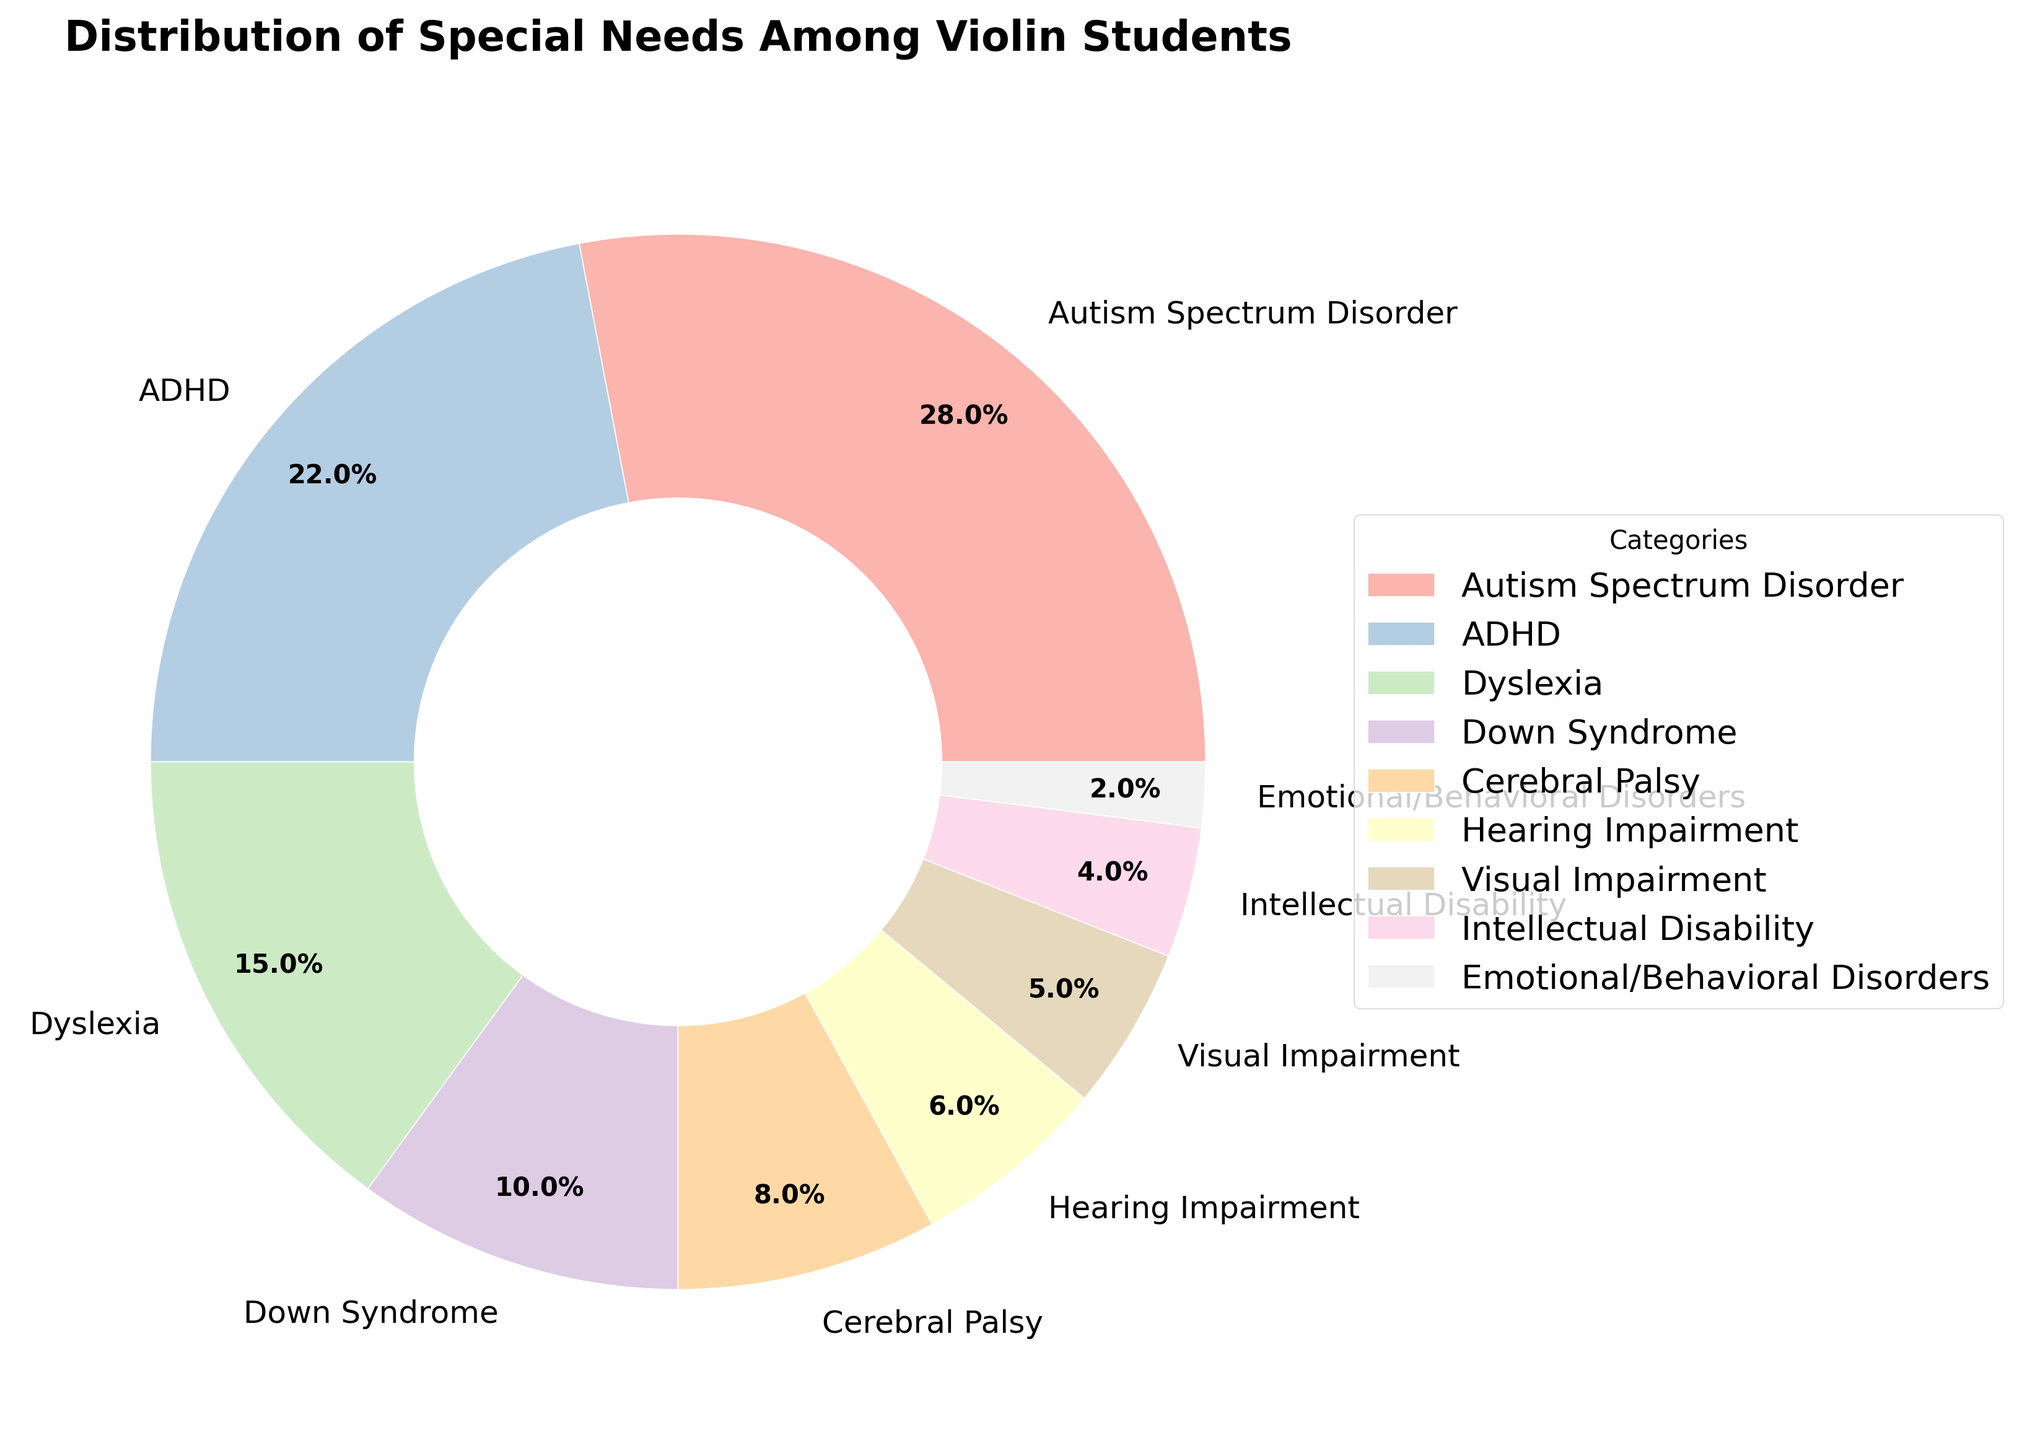What percentage of students have Autism Spectrum Disorder (ASD)? The figure shows a pie chart segment labeled "Autism Spectrum Disorder" with a percentage listed next to it.
Answer: 28% Which category has a higher percentage: ADHD or Dyslexia? Comparing the percentages labeled on the pie chart for ADHD (22%) and Dyslexia (15%), ADHD has a higher percentage than Dyslexia.
Answer: ADHD What is the combined percentage of students with Down Syndrome and Cerebral Palsy? Add the percentages for Down Syndrome (10%) and Cerebral Palsy (8%) as shown in the pie chart. 10% + 8% = 18%
Answer: 18% Which category has the smallest representation among the violin students? Based on the smallest percentage labels on the pie chart, Emotional/Behavioral Disorders has the lowest percentage (2%).
Answer: Emotional/Behavioral Disorders How many categories have a percentage greater than 10%? Identify on the pie chart which categories have percentages over 10%. There are three such categories: Autism Spectrum Disorder (28%), ADHD (22%), and Dyslexia (15%).
Answer: 3 Compare the percentages of students with Hearing Impairment and Visual Impairment. Which one is higher? The pie chart shows that Hearing Impairment is 6% while Visual Impairment is 5%. Thus, Hearing Impairment has a higher percentage.
Answer: Hearing Impairment What’s the total percentage of students with either Intellectual Disability or Emotional/Behavioral Disorders? Add the percentages for Intellectual Disability (4%) and Emotional/Behavioral Disorders (2%). 4% + 2% = 6%
Answer: 6% Are there more students with Autism Spectrum Disorder or ADHD? Compare the percentages: Autism Spectrum Disorder is 28% and ADHD is 22%. Autism Spectrum Disorder has a higher percentage than ADHD.
Answer: Autism Spectrum Disorder What percentage of the students have either Dyslexia or Down Syndrome? Add the percentages for Dyslexia (15%) and Down Syndrome (10%). 15% + 10% = 25%
Answer: 25% Which segment in the pie chart is represented by a slightly smaller area: Dyslexia or Down Syndrome? By visually comparing the segments of the pie chart, the Dyslexia segment is slightly larger than the Down Syndrome segment.
Answer: Down Syndrome 